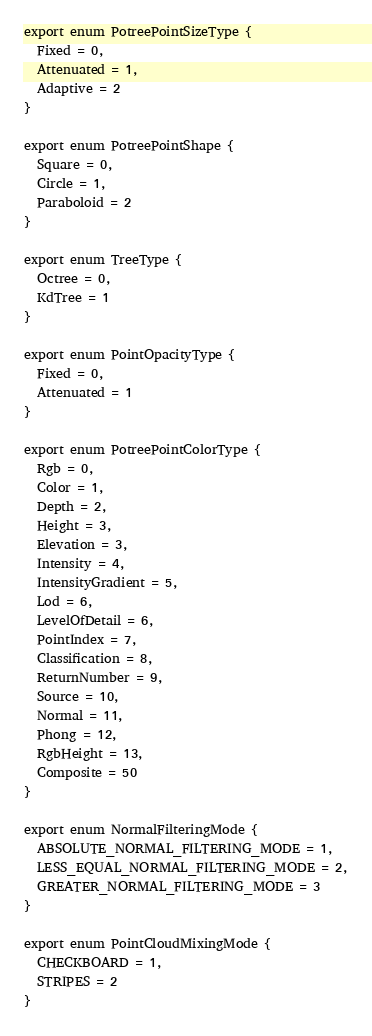<code> <loc_0><loc_0><loc_500><loc_500><_TypeScript_>export enum PotreePointSizeType {
  Fixed = 0,
  Attenuated = 1,
  Adaptive = 2
}

export enum PotreePointShape {
  Square = 0,
  Circle = 1,
  Paraboloid = 2
}

export enum TreeType {
  Octree = 0,
  KdTree = 1
}

export enum PointOpacityType {
  Fixed = 0,
  Attenuated = 1
}

export enum PotreePointColorType {
  Rgb = 0,
  Color = 1,
  Depth = 2,
  Height = 3,
  Elevation = 3,
  Intensity = 4,
  IntensityGradient = 5,
  Lod = 6,
  LevelOfDetail = 6,
  PointIndex = 7,
  Classification = 8,
  ReturnNumber = 9,
  Source = 10,
  Normal = 11,
  Phong = 12,
  RgbHeight = 13,
  Composite = 50
}

export enum NormalFilteringMode {
  ABSOLUTE_NORMAL_FILTERING_MODE = 1,
  LESS_EQUAL_NORMAL_FILTERING_MODE = 2,
  GREATER_NORMAL_FILTERING_MODE = 3
}

export enum PointCloudMixingMode {
  CHECKBOARD = 1,
  STRIPES = 2
}
</code> 